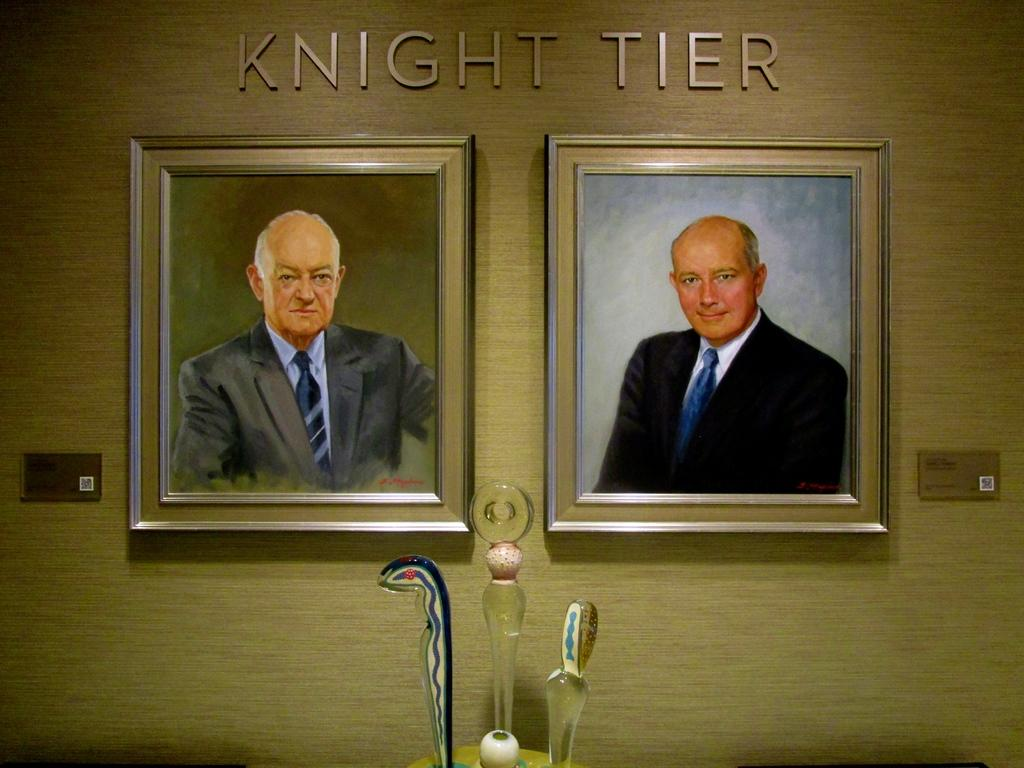<image>
Render a clear and concise summary of the photo. Photo framed of two men under the words Knight tier. 